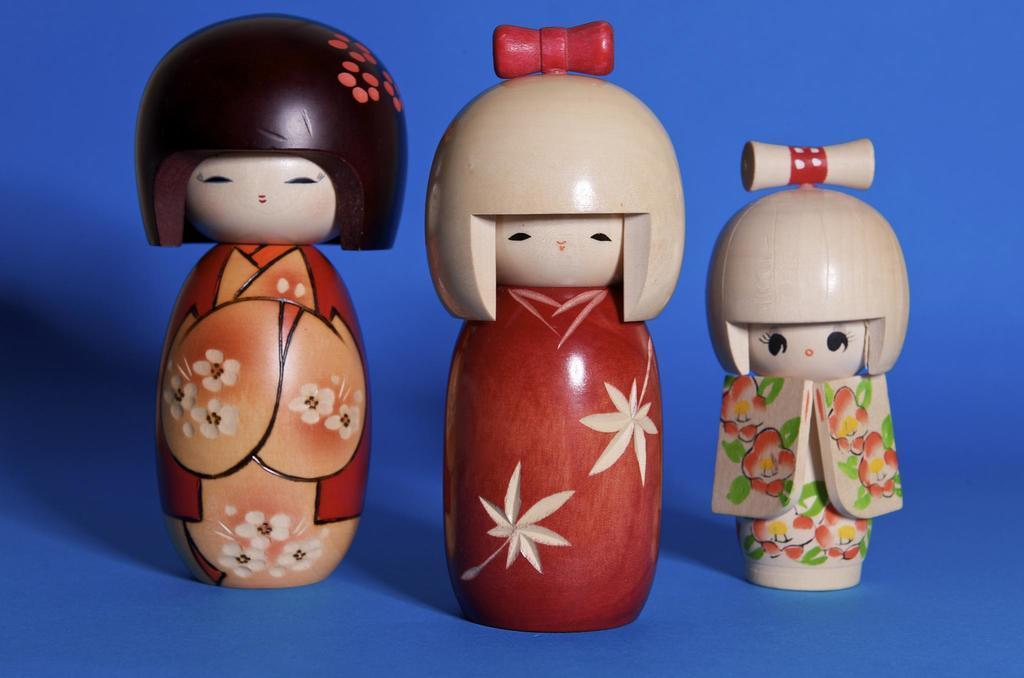In one or two sentences, can you explain what this image depicts? In this image, we can see three toys. In the background, we can see black color. 